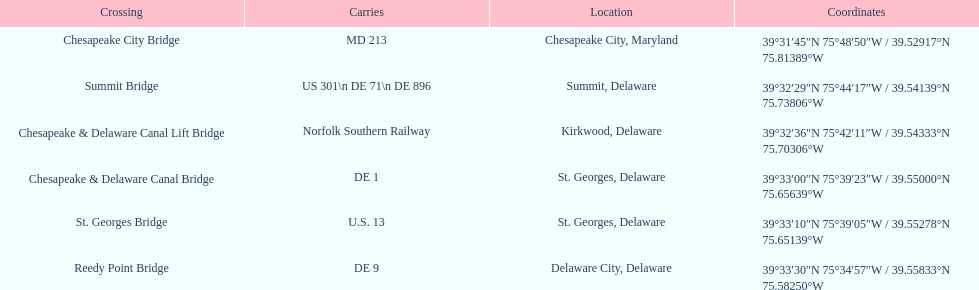Where can the greatest number of routes be found on a crossing (e.g., de 1)? Summit Bridge. 